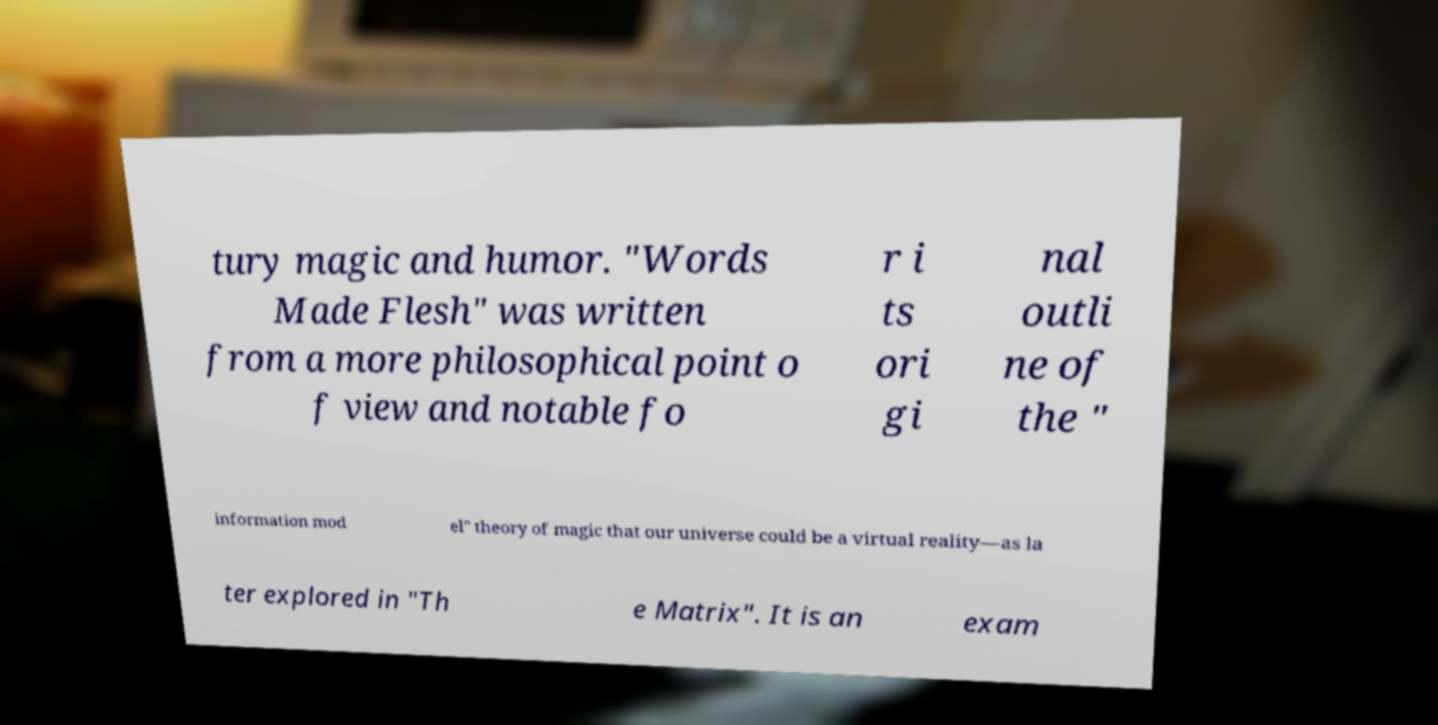I need the written content from this picture converted into text. Can you do that? tury magic and humor. "Words Made Flesh" was written from a more philosophical point o f view and notable fo r i ts ori gi nal outli ne of the " information mod el" theory of magic that our universe could be a virtual reality—as la ter explored in "Th e Matrix". It is an exam 